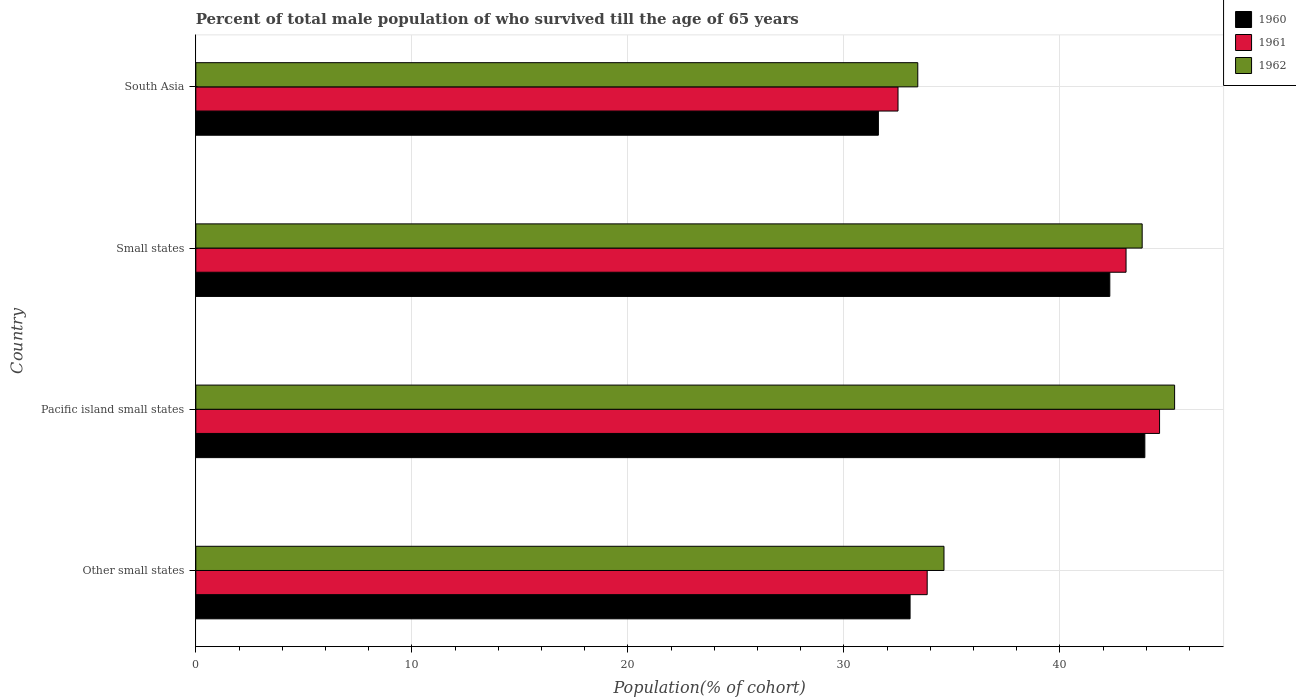How many different coloured bars are there?
Provide a short and direct response. 3. What is the label of the 3rd group of bars from the top?
Your response must be concise. Pacific island small states. What is the percentage of total male population who survived till the age of 65 years in 1960 in South Asia?
Ensure brevity in your answer.  31.6. Across all countries, what is the maximum percentage of total male population who survived till the age of 65 years in 1962?
Your answer should be compact. 45.31. Across all countries, what is the minimum percentage of total male population who survived till the age of 65 years in 1961?
Your answer should be compact. 32.51. In which country was the percentage of total male population who survived till the age of 65 years in 1962 maximum?
Your answer should be very brief. Pacific island small states. In which country was the percentage of total male population who survived till the age of 65 years in 1962 minimum?
Provide a short and direct response. South Asia. What is the total percentage of total male population who survived till the age of 65 years in 1960 in the graph?
Offer a very short reply. 150.91. What is the difference between the percentage of total male population who survived till the age of 65 years in 1960 in Small states and that in South Asia?
Offer a very short reply. 10.71. What is the difference between the percentage of total male population who survived till the age of 65 years in 1962 in Other small states and the percentage of total male population who survived till the age of 65 years in 1960 in Pacific island small states?
Your response must be concise. -9.3. What is the average percentage of total male population who survived till the age of 65 years in 1962 per country?
Provide a short and direct response. 39.29. What is the difference between the percentage of total male population who survived till the age of 65 years in 1960 and percentage of total male population who survived till the age of 65 years in 1962 in South Asia?
Ensure brevity in your answer.  -1.82. What is the ratio of the percentage of total male population who survived till the age of 65 years in 1961 in Other small states to that in South Asia?
Keep it short and to the point. 1.04. Is the percentage of total male population who survived till the age of 65 years in 1961 in Pacific island small states less than that in Small states?
Offer a very short reply. No. What is the difference between the highest and the second highest percentage of total male population who survived till the age of 65 years in 1962?
Provide a succinct answer. 1.5. What is the difference between the highest and the lowest percentage of total male population who survived till the age of 65 years in 1962?
Offer a very short reply. 11.89. What does the 2nd bar from the bottom in Small states represents?
Provide a succinct answer. 1961. What is the difference between two consecutive major ticks on the X-axis?
Provide a short and direct response. 10. Are the values on the major ticks of X-axis written in scientific E-notation?
Provide a succinct answer. No. Does the graph contain grids?
Make the answer very short. Yes. How are the legend labels stacked?
Your response must be concise. Vertical. What is the title of the graph?
Ensure brevity in your answer.  Percent of total male population of who survived till the age of 65 years. What is the label or title of the X-axis?
Your answer should be compact. Population(% of cohort). What is the Population(% of cohort) in 1960 in Other small states?
Provide a short and direct response. 33.07. What is the Population(% of cohort) in 1961 in Other small states?
Ensure brevity in your answer.  33.86. What is the Population(% of cohort) in 1962 in Other small states?
Give a very brief answer. 34.64. What is the Population(% of cohort) of 1960 in Pacific island small states?
Provide a succinct answer. 43.93. What is the Population(% of cohort) in 1961 in Pacific island small states?
Make the answer very short. 44.61. What is the Population(% of cohort) of 1962 in Pacific island small states?
Offer a terse response. 45.31. What is the Population(% of cohort) in 1960 in Small states?
Provide a short and direct response. 42.31. What is the Population(% of cohort) of 1961 in Small states?
Your answer should be very brief. 43.06. What is the Population(% of cohort) of 1962 in Small states?
Offer a terse response. 43.81. What is the Population(% of cohort) in 1960 in South Asia?
Keep it short and to the point. 31.6. What is the Population(% of cohort) of 1961 in South Asia?
Give a very brief answer. 32.51. What is the Population(% of cohort) of 1962 in South Asia?
Keep it short and to the point. 33.42. Across all countries, what is the maximum Population(% of cohort) in 1960?
Give a very brief answer. 43.93. Across all countries, what is the maximum Population(% of cohort) of 1961?
Your answer should be very brief. 44.61. Across all countries, what is the maximum Population(% of cohort) of 1962?
Offer a very short reply. 45.31. Across all countries, what is the minimum Population(% of cohort) of 1960?
Your answer should be compact. 31.6. Across all countries, what is the minimum Population(% of cohort) in 1961?
Offer a very short reply. 32.51. Across all countries, what is the minimum Population(% of cohort) of 1962?
Your answer should be compact. 33.42. What is the total Population(% of cohort) of 1960 in the graph?
Your answer should be very brief. 150.91. What is the total Population(% of cohort) in 1961 in the graph?
Keep it short and to the point. 154.04. What is the total Population(% of cohort) in 1962 in the graph?
Make the answer very short. 157.18. What is the difference between the Population(% of cohort) in 1960 in Other small states and that in Pacific island small states?
Give a very brief answer. -10.87. What is the difference between the Population(% of cohort) of 1961 in Other small states and that in Pacific island small states?
Your response must be concise. -10.76. What is the difference between the Population(% of cohort) of 1962 in Other small states and that in Pacific island small states?
Offer a terse response. -10.68. What is the difference between the Population(% of cohort) in 1960 in Other small states and that in Small states?
Your answer should be very brief. -9.25. What is the difference between the Population(% of cohort) in 1961 in Other small states and that in Small states?
Ensure brevity in your answer.  -9.21. What is the difference between the Population(% of cohort) of 1962 in Other small states and that in Small states?
Your answer should be compact. -9.17. What is the difference between the Population(% of cohort) of 1960 in Other small states and that in South Asia?
Offer a terse response. 1.47. What is the difference between the Population(% of cohort) of 1961 in Other small states and that in South Asia?
Make the answer very short. 1.35. What is the difference between the Population(% of cohort) in 1962 in Other small states and that in South Asia?
Your answer should be very brief. 1.21. What is the difference between the Population(% of cohort) in 1960 in Pacific island small states and that in Small states?
Provide a succinct answer. 1.62. What is the difference between the Population(% of cohort) in 1961 in Pacific island small states and that in Small states?
Provide a short and direct response. 1.55. What is the difference between the Population(% of cohort) of 1962 in Pacific island small states and that in Small states?
Offer a terse response. 1.5. What is the difference between the Population(% of cohort) in 1960 in Pacific island small states and that in South Asia?
Offer a terse response. 12.33. What is the difference between the Population(% of cohort) of 1961 in Pacific island small states and that in South Asia?
Offer a very short reply. 12.11. What is the difference between the Population(% of cohort) in 1962 in Pacific island small states and that in South Asia?
Ensure brevity in your answer.  11.89. What is the difference between the Population(% of cohort) of 1960 in Small states and that in South Asia?
Provide a succinct answer. 10.71. What is the difference between the Population(% of cohort) of 1961 in Small states and that in South Asia?
Give a very brief answer. 10.56. What is the difference between the Population(% of cohort) of 1962 in Small states and that in South Asia?
Make the answer very short. 10.39. What is the difference between the Population(% of cohort) in 1960 in Other small states and the Population(% of cohort) in 1961 in Pacific island small states?
Ensure brevity in your answer.  -11.55. What is the difference between the Population(% of cohort) in 1960 in Other small states and the Population(% of cohort) in 1962 in Pacific island small states?
Keep it short and to the point. -12.25. What is the difference between the Population(% of cohort) of 1961 in Other small states and the Population(% of cohort) of 1962 in Pacific island small states?
Offer a terse response. -11.45. What is the difference between the Population(% of cohort) in 1960 in Other small states and the Population(% of cohort) in 1961 in Small states?
Provide a succinct answer. -10. What is the difference between the Population(% of cohort) of 1960 in Other small states and the Population(% of cohort) of 1962 in Small states?
Offer a very short reply. -10.74. What is the difference between the Population(% of cohort) of 1961 in Other small states and the Population(% of cohort) of 1962 in Small states?
Provide a short and direct response. -9.95. What is the difference between the Population(% of cohort) in 1960 in Other small states and the Population(% of cohort) in 1961 in South Asia?
Give a very brief answer. 0.56. What is the difference between the Population(% of cohort) in 1960 in Other small states and the Population(% of cohort) in 1962 in South Asia?
Keep it short and to the point. -0.36. What is the difference between the Population(% of cohort) in 1961 in Other small states and the Population(% of cohort) in 1962 in South Asia?
Your answer should be very brief. 0.44. What is the difference between the Population(% of cohort) in 1960 in Pacific island small states and the Population(% of cohort) in 1961 in Small states?
Your answer should be very brief. 0.87. What is the difference between the Population(% of cohort) of 1960 in Pacific island small states and the Population(% of cohort) of 1962 in Small states?
Keep it short and to the point. 0.12. What is the difference between the Population(% of cohort) of 1961 in Pacific island small states and the Population(% of cohort) of 1962 in Small states?
Make the answer very short. 0.81. What is the difference between the Population(% of cohort) of 1960 in Pacific island small states and the Population(% of cohort) of 1961 in South Asia?
Offer a terse response. 11.43. What is the difference between the Population(% of cohort) in 1960 in Pacific island small states and the Population(% of cohort) in 1962 in South Asia?
Your answer should be very brief. 10.51. What is the difference between the Population(% of cohort) of 1961 in Pacific island small states and the Population(% of cohort) of 1962 in South Asia?
Offer a very short reply. 11.19. What is the difference between the Population(% of cohort) of 1960 in Small states and the Population(% of cohort) of 1961 in South Asia?
Provide a short and direct response. 9.8. What is the difference between the Population(% of cohort) in 1960 in Small states and the Population(% of cohort) in 1962 in South Asia?
Provide a succinct answer. 8.89. What is the difference between the Population(% of cohort) in 1961 in Small states and the Population(% of cohort) in 1962 in South Asia?
Provide a short and direct response. 9.64. What is the average Population(% of cohort) of 1960 per country?
Your answer should be compact. 37.73. What is the average Population(% of cohort) in 1961 per country?
Provide a succinct answer. 38.51. What is the average Population(% of cohort) of 1962 per country?
Offer a terse response. 39.29. What is the difference between the Population(% of cohort) of 1960 and Population(% of cohort) of 1961 in Other small states?
Offer a terse response. -0.79. What is the difference between the Population(% of cohort) of 1960 and Population(% of cohort) of 1962 in Other small states?
Offer a terse response. -1.57. What is the difference between the Population(% of cohort) in 1961 and Population(% of cohort) in 1962 in Other small states?
Offer a very short reply. -0.78. What is the difference between the Population(% of cohort) of 1960 and Population(% of cohort) of 1961 in Pacific island small states?
Give a very brief answer. -0.68. What is the difference between the Population(% of cohort) of 1960 and Population(% of cohort) of 1962 in Pacific island small states?
Your answer should be very brief. -1.38. What is the difference between the Population(% of cohort) of 1961 and Population(% of cohort) of 1962 in Pacific island small states?
Your answer should be compact. -0.7. What is the difference between the Population(% of cohort) in 1960 and Population(% of cohort) in 1961 in Small states?
Your response must be concise. -0.75. What is the difference between the Population(% of cohort) in 1960 and Population(% of cohort) in 1962 in Small states?
Your answer should be very brief. -1.5. What is the difference between the Population(% of cohort) of 1961 and Population(% of cohort) of 1962 in Small states?
Your answer should be very brief. -0.75. What is the difference between the Population(% of cohort) of 1960 and Population(% of cohort) of 1961 in South Asia?
Ensure brevity in your answer.  -0.91. What is the difference between the Population(% of cohort) of 1960 and Population(% of cohort) of 1962 in South Asia?
Your answer should be compact. -1.82. What is the difference between the Population(% of cohort) in 1961 and Population(% of cohort) in 1962 in South Asia?
Offer a terse response. -0.91. What is the ratio of the Population(% of cohort) in 1960 in Other small states to that in Pacific island small states?
Ensure brevity in your answer.  0.75. What is the ratio of the Population(% of cohort) in 1961 in Other small states to that in Pacific island small states?
Give a very brief answer. 0.76. What is the ratio of the Population(% of cohort) of 1962 in Other small states to that in Pacific island small states?
Your answer should be compact. 0.76. What is the ratio of the Population(% of cohort) of 1960 in Other small states to that in Small states?
Your answer should be compact. 0.78. What is the ratio of the Population(% of cohort) of 1961 in Other small states to that in Small states?
Your answer should be compact. 0.79. What is the ratio of the Population(% of cohort) in 1962 in Other small states to that in Small states?
Make the answer very short. 0.79. What is the ratio of the Population(% of cohort) in 1960 in Other small states to that in South Asia?
Your answer should be very brief. 1.05. What is the ratio of the Population(% of cohort) in 1961 in Other small states to that in South Asia?
Your answer should be compact. 1.04. What is the ratio of the Population(% of cohort) in 1962 in Other small states to that in South Asia?
Offer a very short reply. 1.04. What is the ratio of the Population(% of cohort) of 1960 in Pacific island small states to that in Small states?
Provide a succinct answer. 1.04. What is the ratio of the Population(% of cohort) of 1961 in Pacific island small states to that in Small states?
Keep it short and to the point. 1.04. What is the ratio of the Population(% of cohort) in 1962 in Pacific island small states to that in Small states?
Ensure brevity in your answer.  1.03. What is the ratio of the Population(% of cohort) in 1960 in Pacific island small states to that in South Asia?
Ensure brevity in your answer.  1.39. What is the ratio of the Population(% of cohort) of 1961 in Pacific island small states to that in South Asia?
Your answer should be compact. 1.37. What is the ratio of the Population(% of cohort) of 1962 in Pacific island small states to that in South Asia?
Keep it short and to the point. 1.36. What is the ratio of the Population(% of cohort) of 1960 in Small states to that in South Asia?
Make the answer very short. 1.34. What is the ratio of the Population(% of cohort) in 1961 in Small states to that in South Asia?
Your answer should be very brief. 1.32. What is the ratio of the Population(% of cohort) in 1962 in Small states to that in South Asia?
Your response must be concise. 1.31. What is the difference between the highest and the second highest Population(% of cohort) in 1960?
Provide a short and direct response. 1.62. What is the difference between the highest and the second highest Population(% of cohort) of 1961?
Ensure brevity in your answer.  1.55. What is the difference between the highest and the second highest Population(% of cohort) in 1962?
Ensure brevity in your answer.  1.5. What is the difference between the highest and the lowest Population(% of cohort) in 1960?
Your answer should be very brief. 12.33. What is the difference between the highest and the lowest Population(% of cohort) of 1961?
Give a very brief answer. 12.11. What is the difference between the highest and the lowest Population(% of cohort) in 1962?
Provide a short and direct response. 11.89. 